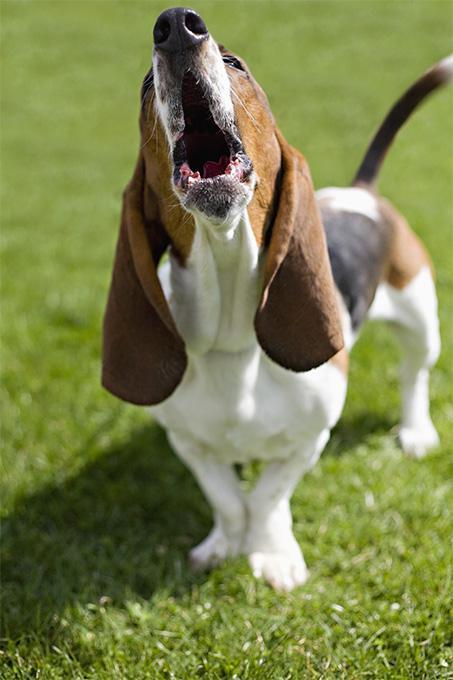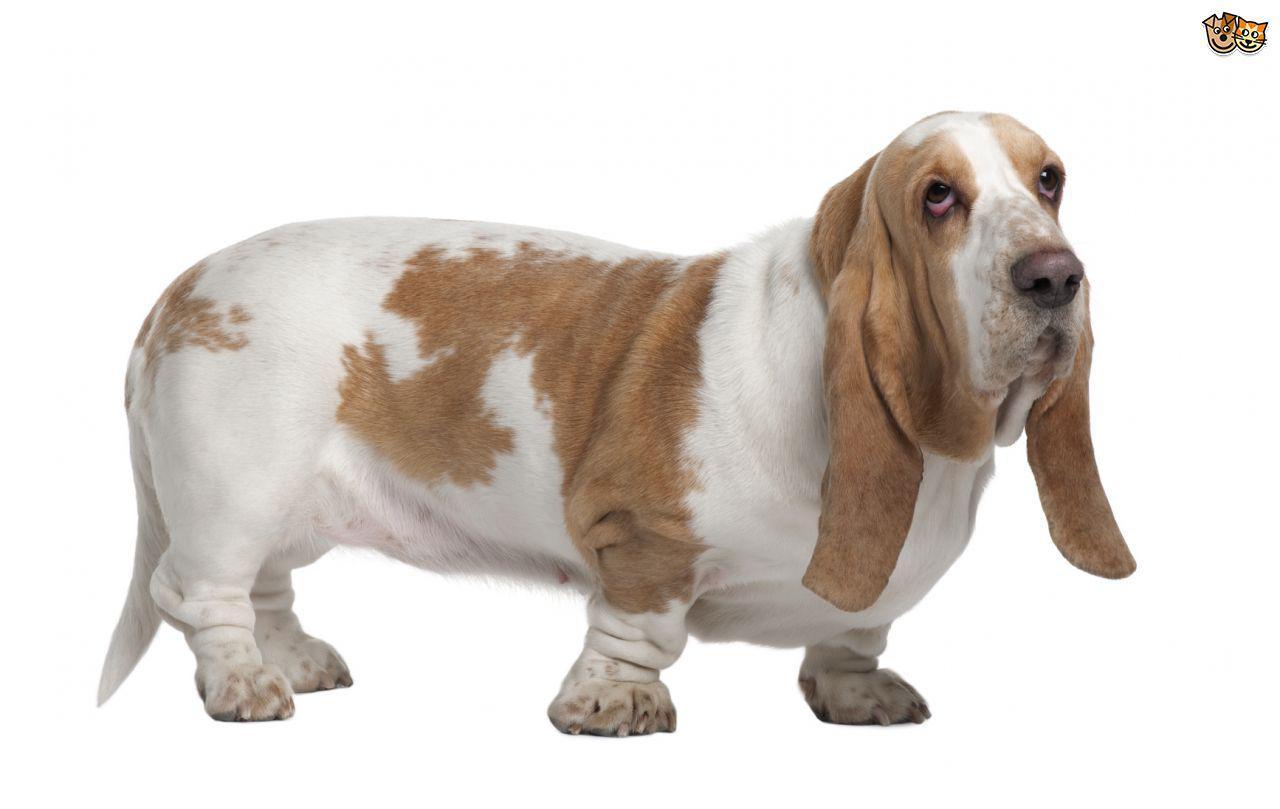The first image is the image on the left, the second image is the image on the right. Assess this claim about the two images: "An image shows one forward-turned basset hound, which has its mouth open fairly wide.". Correct or not? Answer yes or no. Yes. The first image is the image on the left, the second image is the image on the right. For the images shown, is this caption "The mouth of the dog in the image on the left is open." true? Answer yes or no. Yes. 